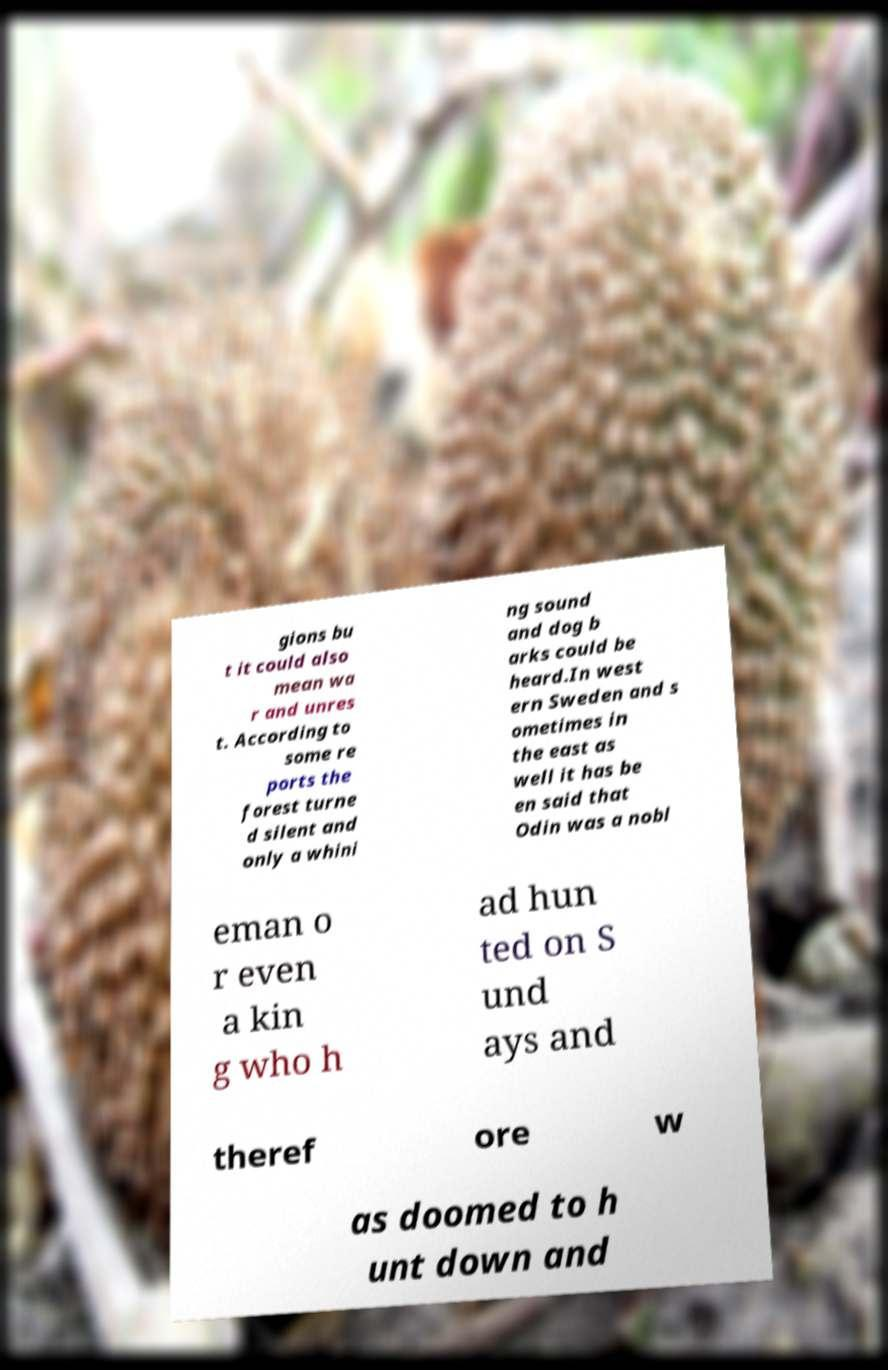Can you accurately transcribe the text from the provided image for me? gions bu t it could also mean wa r and unres t. According to some re ports the forest turne d silent and only a whini ng sound and dog b arks could be heard.In west ern Sweden and s ometimes in the east as well it has be en said that Odin was a nobl eman o r even a kin g who h ad hun ted on S und ays and theref ore w as doomed to h unt down and 